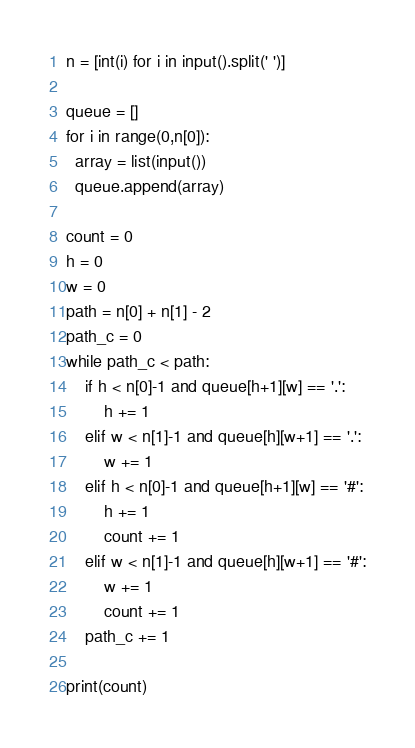Convert code to text. <code><loc_0><loc_0><loc_500><loc_500><_Python_>n = [int(i) for i in input().split(' ')]

queue = []
for i in range(0,n[0]):
  array = list(input())
  queue.append(array)

count = 0
h = 0
w = 0
path = n[0] + n[1] - 2
path_c = 0
while path_c < path:
    if h < n[0]-1 and queue[h+1][w] == '.':
        h += 1
    elif w < n[1]-1 and queue[h][w+1] == '.':
        w += 1
    elif h < n[0]-1 and queue[h+1][w] == '#':
        h += 1
        count += 1
    elif w < n[1]-1 and queue[h][w+1] == '#':
        w += 1
        count += 1
    path_c += 1

print(count)</code> 